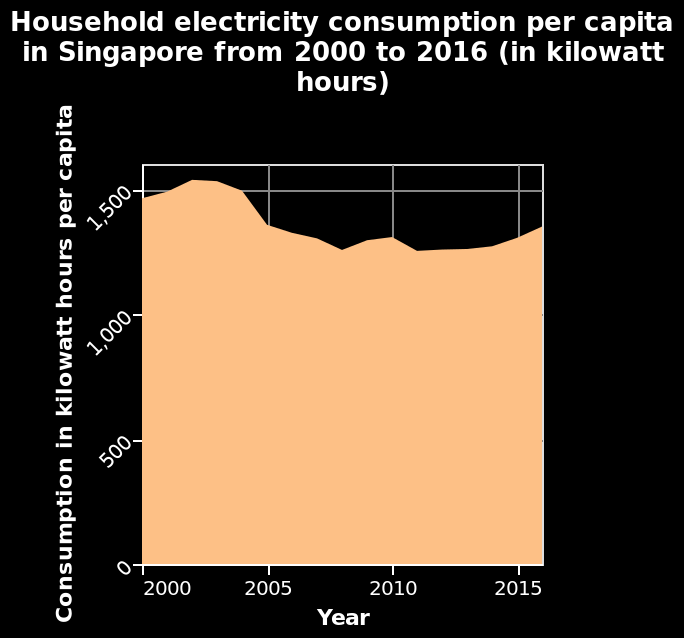<image>
What was the trend in household electricity consumption per capita in Singapore from 2000 to 2016?  Household electricity consumption per capita in Singapore initially decreased from 2000 to 2011 but then increased slightly from 2011 to 2016. What is the title of the area chart?  The title of the area chart is "Household electricity consumption per capita in Singapore from 2000 to 2016 (in kilowatt hours)." 